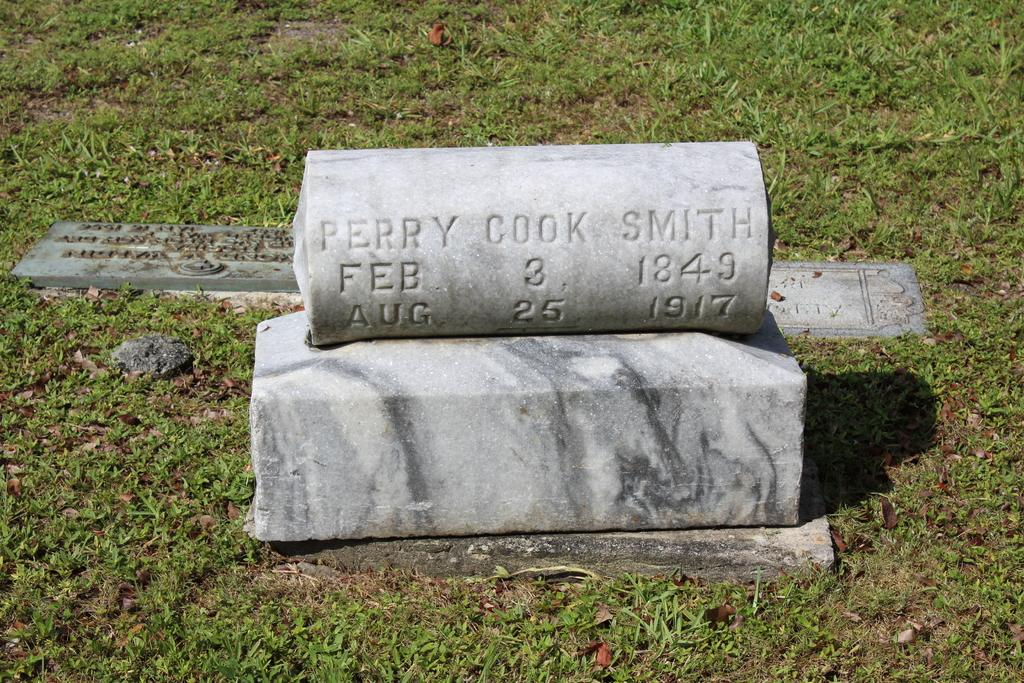How many tombstones are visible in the image? There are three tombstones in the image. What can be found on the tombstones? There is writing on the tombstones. What type of vegetation is present around the tombstones? There is grass around the tombstones. What type of pear can be seen growing on the tombstones in the image? There are no pears present in the image, and they cannot grow on tombstones. 